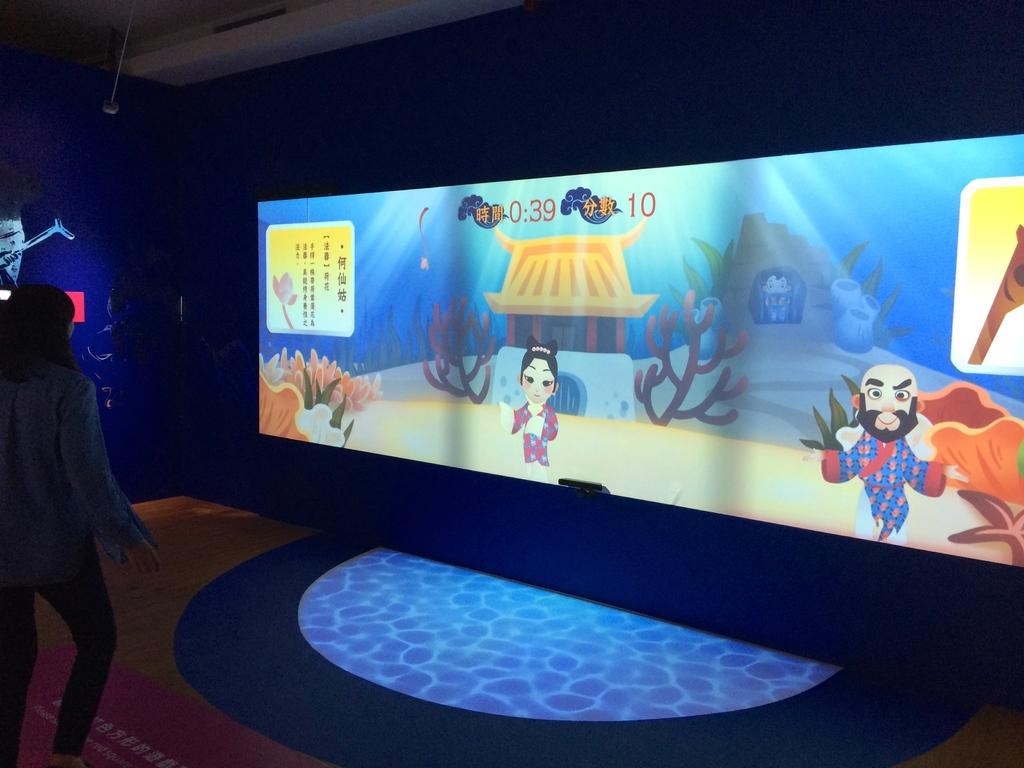What is the main object in the image? There is a screen in the image. What can be seen on the wall in the image? There is a blue color wall in the image. Where is the person located in the image? The person is standing on the left side of the image. How would you describe the lighting in the image? The image appears to be a little dark. What type of behavior do the chickens exhibit in the image? There are no chickens present in the image, so it is not possible to describe their behavior. 